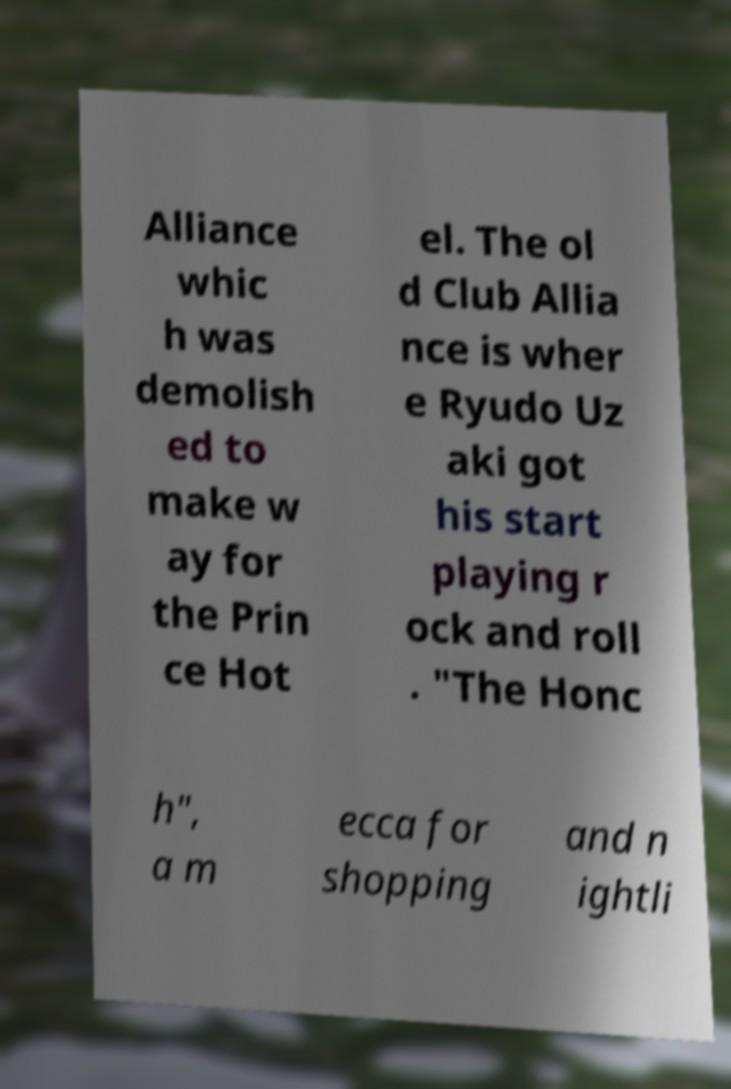Can you read and provide the text displayed in the image?This photo seems to have some interesting text. Can you extract and type it out for me? Alliance whic h was demolish ed to make w ay for the Prin ce Hot el. The ol d Club Allia nce is wher e Ryudo Uz aki got his start playing r ock and roll . "The Honc h", a m ecca for shopping and n ightli 